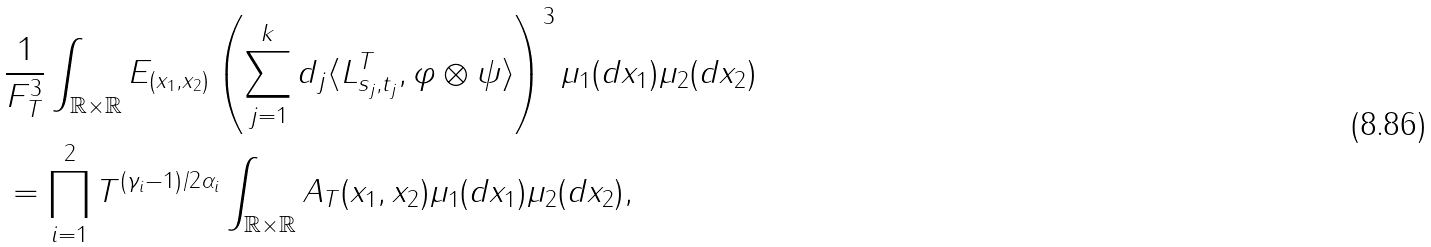<formula> <loc_0><loc_0><loc_500><loc_500>& \frac { 1 } { F _ { T } ^ { 3 } } \int _ { \mathbb { R } \times \mathbb { R } } E _ { ( x _ { 1 } , x _ { 2 } ) } \left ( \sum _ { j = 1 } ^ { k } d _ { j } \langle L ^ { T } _ { s _ { j } , t _ { j } } , \varphi \otimes \psi \rangle \right ) ^ { 3 } \mu _ { 1 } ( d x _ { 1 } ) \mu _ { 2 } ( d x _ { 2 } ) \\ & = \prod _ { i = 1 } ^ { 2 } T ^ { ( \gamma _ { i } - 1 ) / 2 \alpha _ { i } } \int _ { \mathbb { R } \times \mathbb { R } } A _ { T } ( x _ { 1 } , x _ { 2 } ) \mu _ { 1 } ( d x _ { 1 } ) \mu _ { 2 } ( d x _ { 2 } ) ,</formula> 